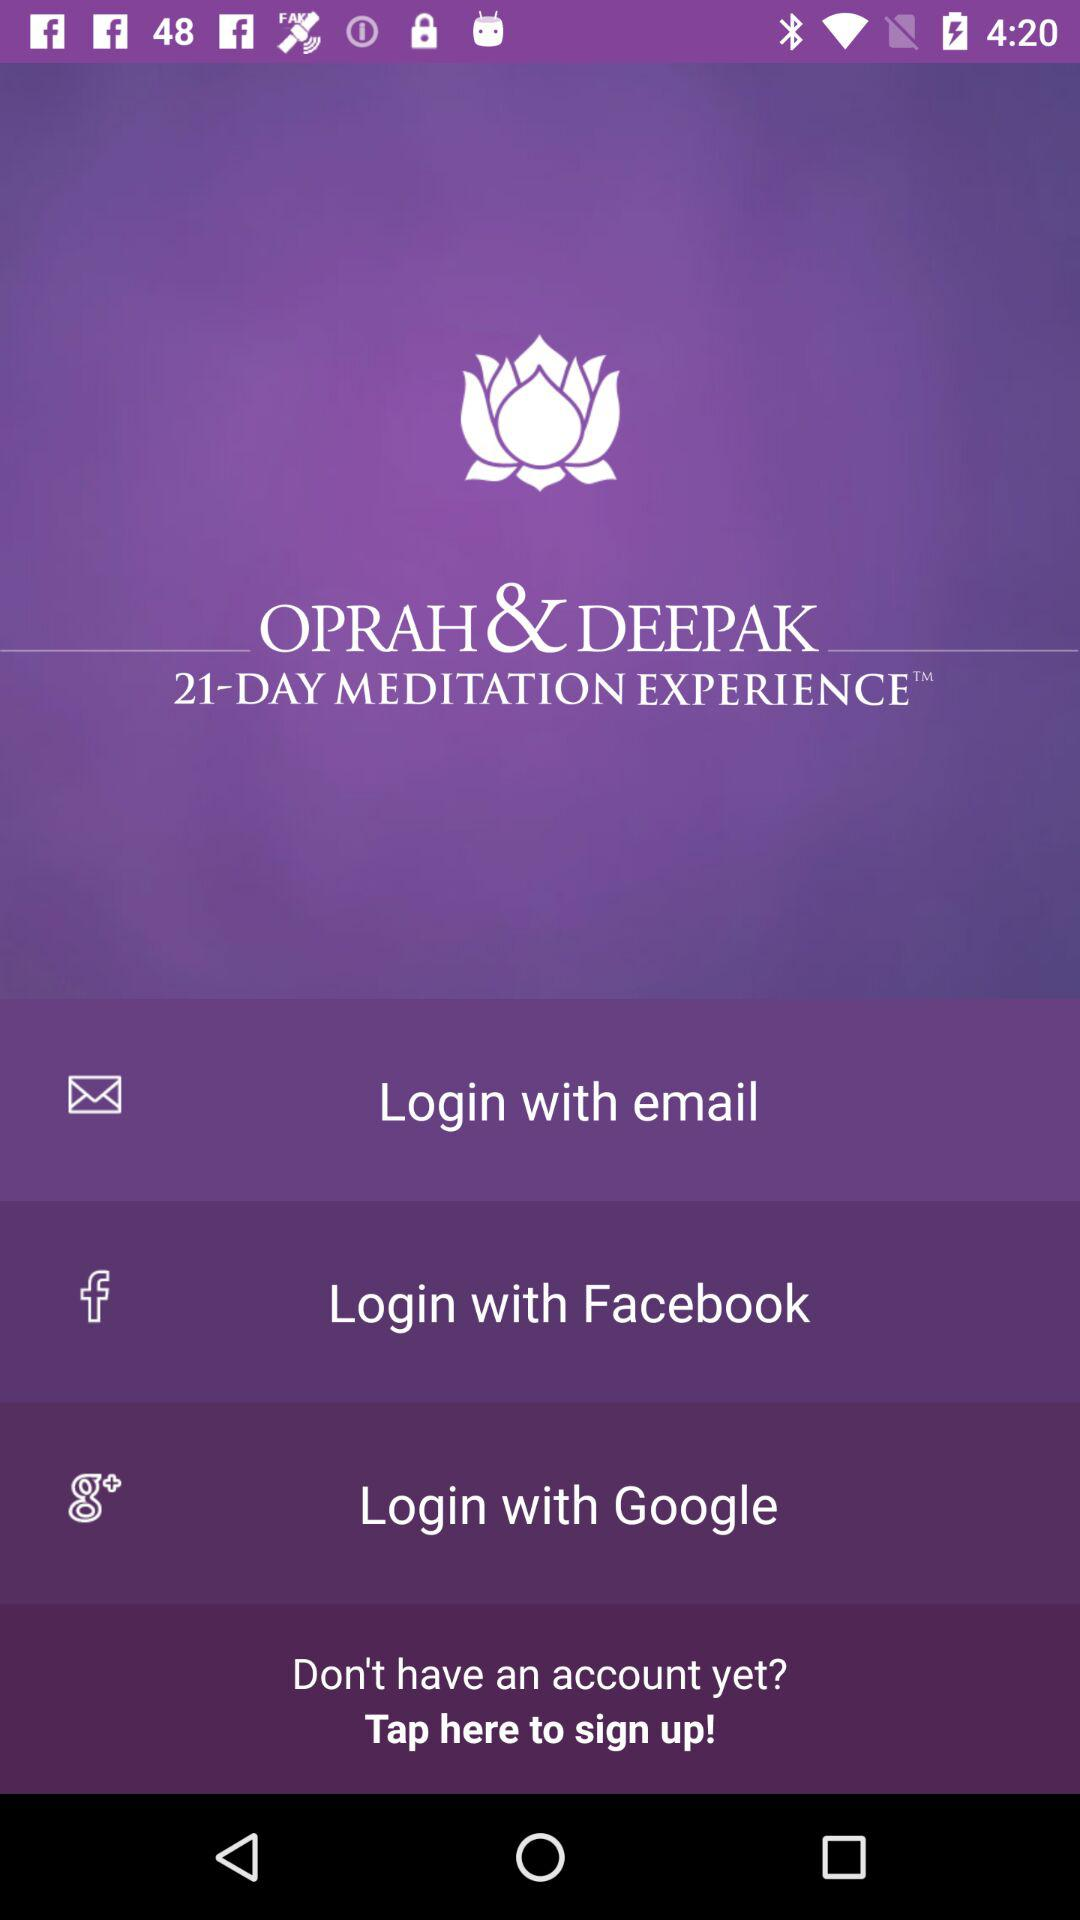How many login options are available?
Answer the question using a single word or phrase. 3 